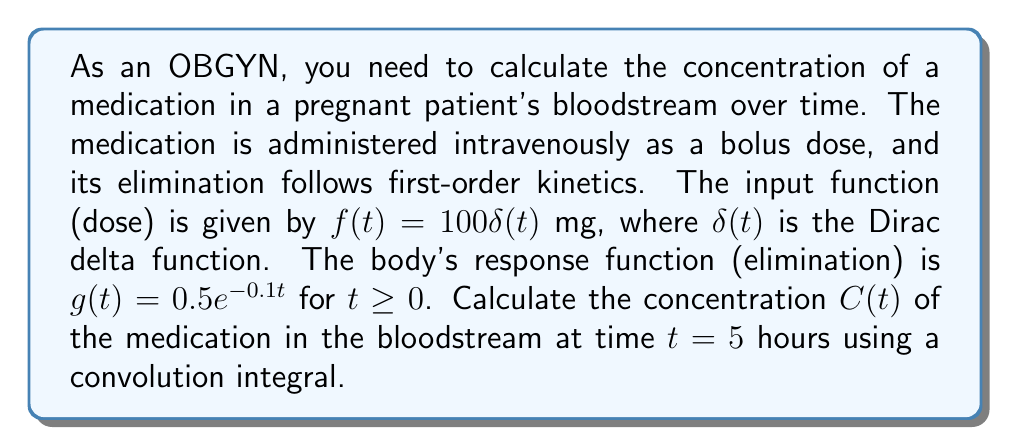Can you solve this math problem? To solve this problem, we'll use the convolution integral to calculate the concentration of the medication over time. The steps are as follows:

1) The convolution integral for the concentration $C(t)$ is given by:

   $$C(t) = (f * g)(t) = \int_{0}^{t} f(\tau)g(t-\tau)d\tau$$

2) Substitute the given functions:

   $$C(t) = \int_{0}^{t} 100\delta(\tau) \cdot 0.5e^{-0.1(t-\tau)}d\tau$$

3) The Dirac delta function has the sifting property:

   $$\int_{-\infty}^{\infty} f(x)\delta(x-a)dx = f(a)$$

4) Applying this property to our integral:

   $$C(t) = 100 \cdot 0.5e^{-0.1(t-0)} = 50e^{-0.1t}$$

5) Now we have the general solution for $C(t)$. To find the concentration at $t = 5$ hours:

   $$C(5) = 50e^{-0.1(5)} = 50e^{-0.5}$$

6) Calculate the final result:

   $$C(5) = 50 \cdot 0.6065 = 30.325$$ mg/L
Answer: $30.325$ mg/L 